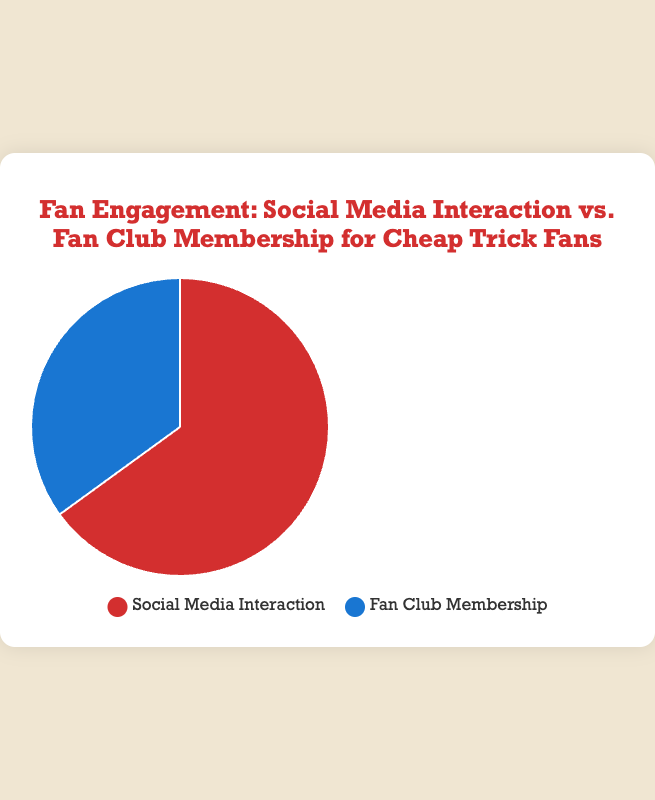What is the total percentage for both categories? Summing up the percentages of Social Media Interaction (65%) and Fan Club Membership (35%) gives 65 + 35 = 100
Answer: 100 Which category has a higher engagement? Comparing the two categories, Social Media Interaction has 65% engagement while Fan Club Membership has 35%. 65 is greater than 35
Answer: Social Media Interaction By how much does Social Media Interaction exceed Fan Club Membership? Subtracting the percentage of Fan Club Membership (35%) from Social Media Interaction (65%) gives 65 - 35 = 30
Answer: 30 What percentage of fan engagement comes from Social Media Interaction? According to the figure, Social Media Interaction accounts for 65% of fan engagement
Answer: 65% What percentage of fan engagement comes from Fan Club Membership? According to the figure, Fan Club Membership accounts for 35% of fan engagement
Answer: 35% What is the ratio of Social Media Interaction to Fan Club Membership? The ratio is given as Social Media Interaction (65%) to Fan Club Membership (35%), which simplifies to 65:35. This can be simplified further to 13:7
Answer: 13:7 If one-third of Social Media Interaction also joined the fan club, what would be the new fan club membership percentage? One-third of Social Media Interaction (65%) is 65 / 3 ≈ 21.67%. Adding this to the Fan Club Membership percentage gives 35 + 21.67 = 56.67%
Answer: 56.67% If the total number of Cheap Trick fans is 10,000, how many members are in the fan club? The Fan Club Membership represents 35% of total fans. So, 35% of 10,000 fans is 10,000 * 0.35 = 3,500
Answer: 3,500 What visual attributes differentiate Social Media Interaction from Fan Club Membership in the pie chart? Social Media Interaction is represented by a red color while Fan Club Membership is represented by a blue color
Answer: Colors (red and blue) What portion of the total engagement is represented by each category combined as a fraction? Both categories together make 100%, which is represented as 100/100 = 1 whole or 1
Answer: 1 